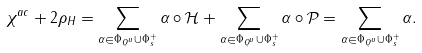Convert formula to latex. <formula><loc_0><loc_0><loc_500><loc_500>\chi ^ { a c } + 2 \rho _ { H } = \sum _ { \alpha \in \Phi _ { Q ^ { u } } \cup \Phi _ { s } ^ { + } } \alpha \circ \mathcal { H } + \sum _ { \alpha \in \Phi _ { Q ^ { u } } \cup \Phi _ { s } ^ { + } } \alpha \circ \mathcal { P } = \sum _ { \alpha \in \Phi _ { Q ^ { u } } \cup \Phi _ { s } ^ { + } } \alpha .</formula> 